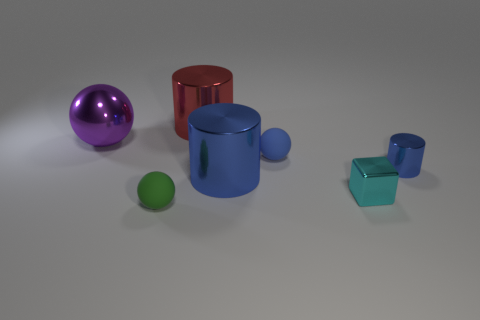Add 3 tiny blue spheres. How many objects exist? 10 Subtract all blocks. How many objects are left? 6 Subtract 0 yellow cylinders. How many objects are left? 7 Subtract all small cyan metal objects. Subtract all small blue cylinders. How many objects are left? 5 Add 5 blue things. How many blue things are left? 8 Add 2 big red things. How many big red things exist? 3 